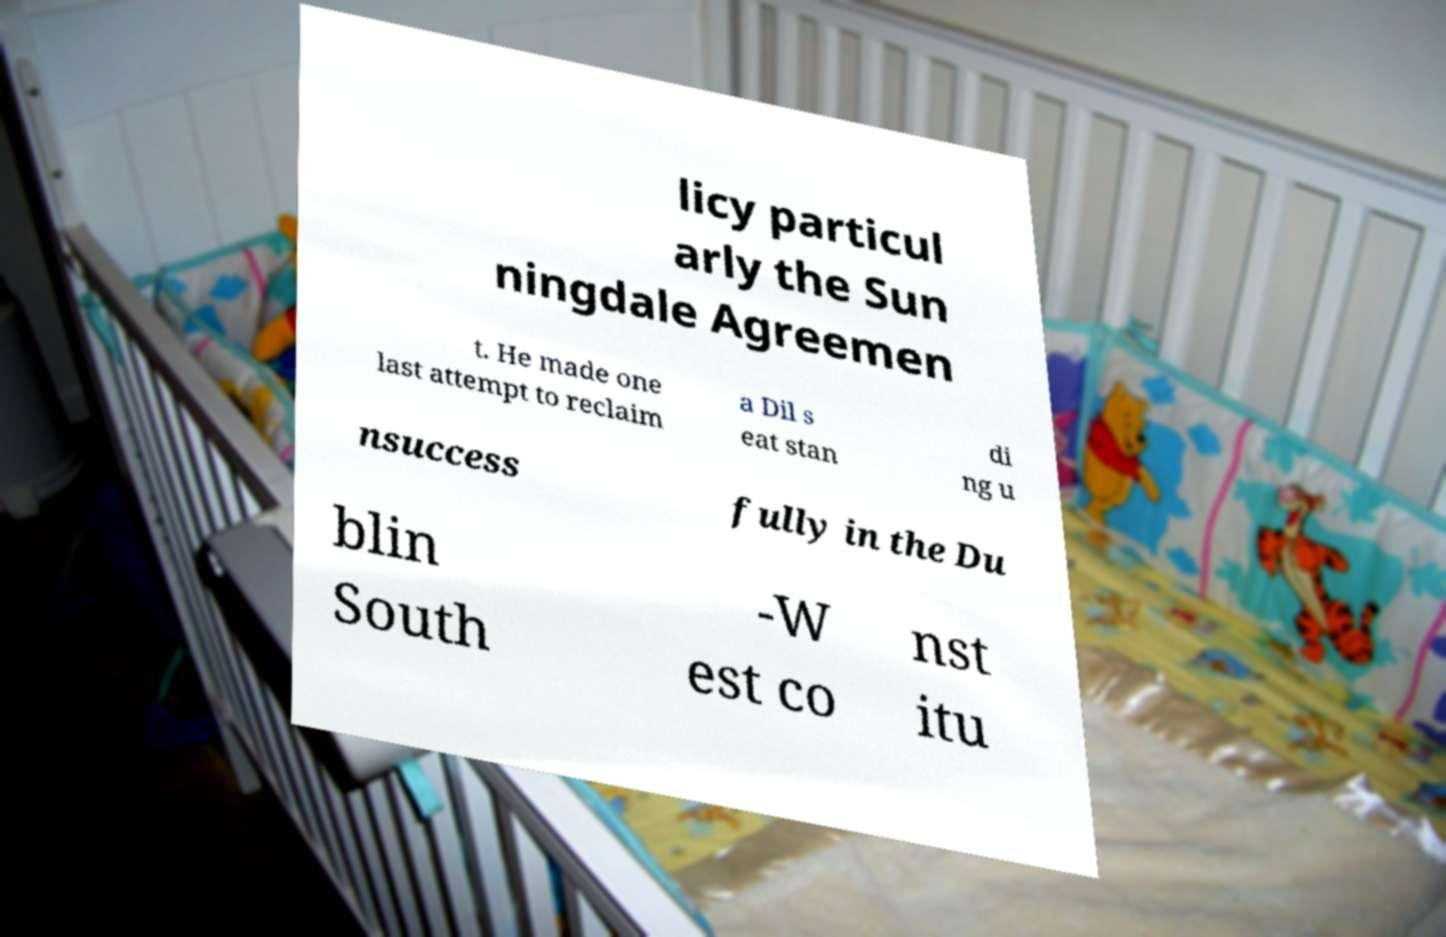Can you accurately transcribe the text from the provided image for me? licy particul arly the Sun ningdale Agreemen t. He made one last attempt to reclaim a Dil s eat stan di ng u nsuccess fully in the Du blin South -W est co nst itu 